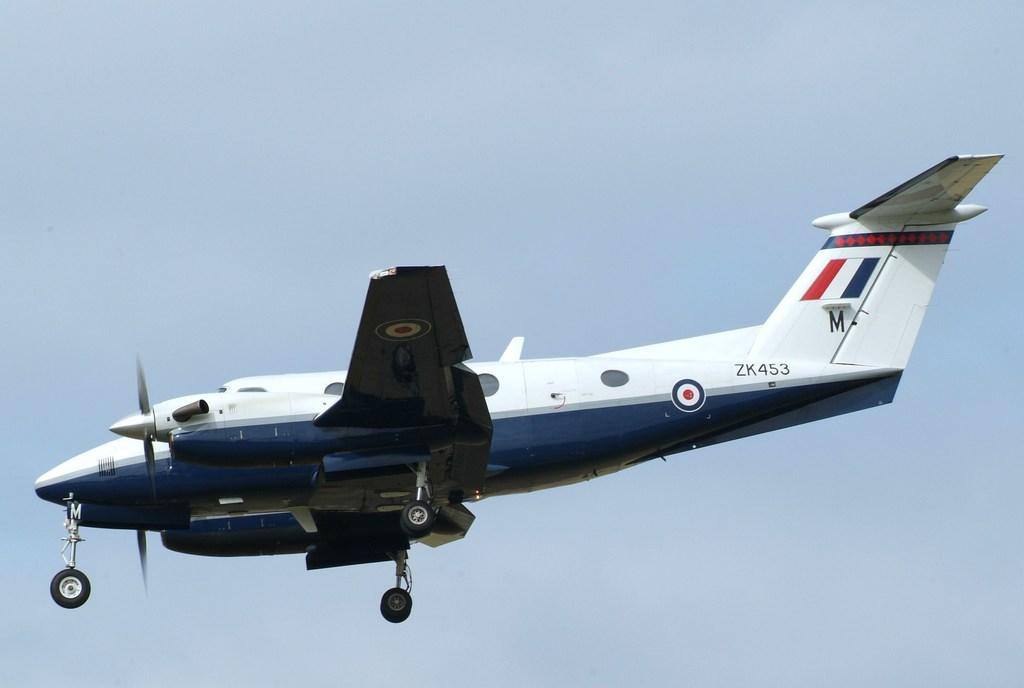Provide a one-sentence caption for the provided image. A blue and white plane with the I.D. ZK453 on the side. 